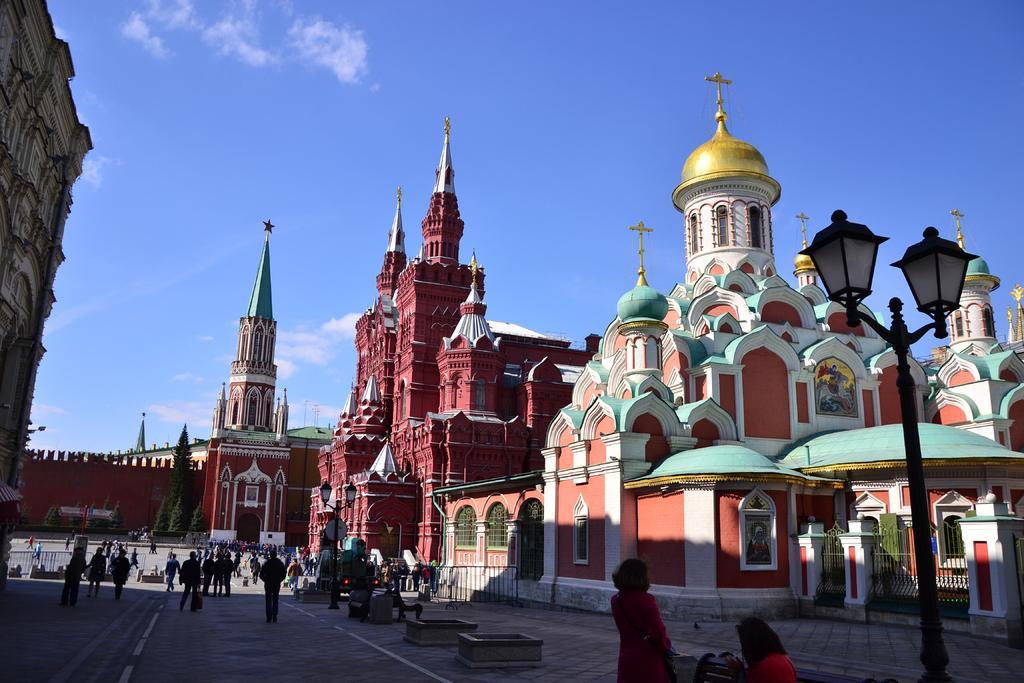Can you describe this image briefly? In this image I can see group of people some are standing and some are walking. In the background I can see few light poles, buildings in multi color and the sky is in blue and white color. 